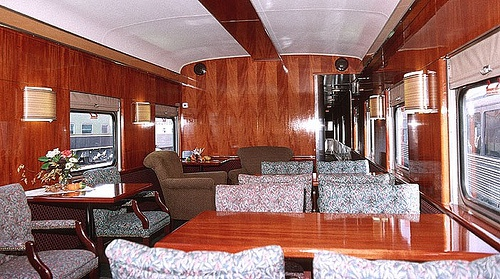Describe the objects in this image and their specific colors. I can see dining table in lavender, brown, and red tones, chair in lavender, gray, black, and darkgray tones, chair in lavender, darkgray, and pink tones, oven in lavender, darkgray, gray, and lightpink tones, and train in lavender, darkgray, gray, and lightpink tones in this image. 